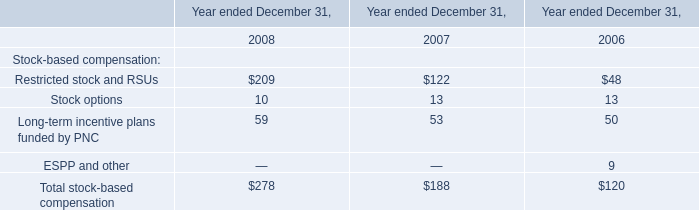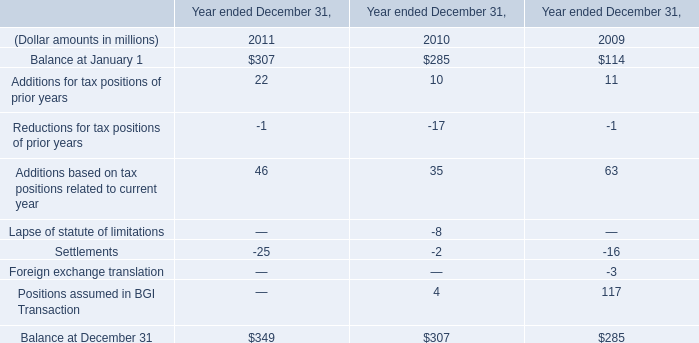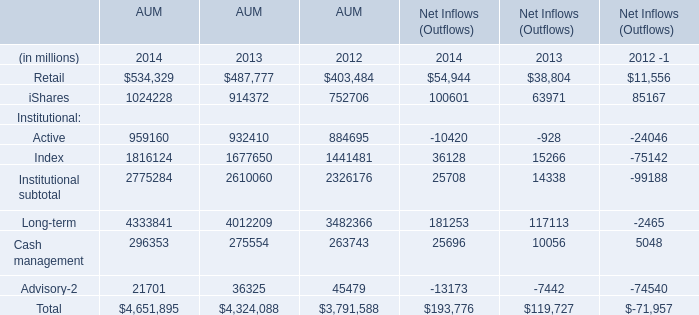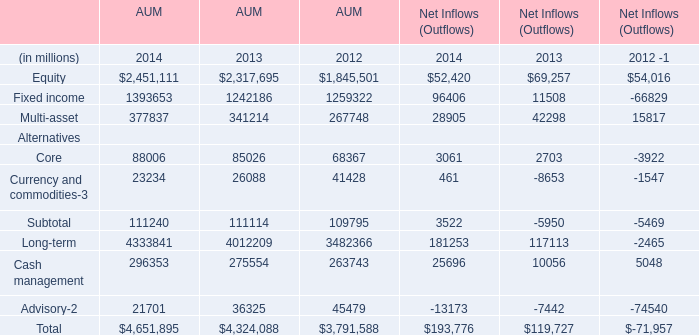What is the average amount of Retail of AUM 2013, and Fixed income of AUM 2013 ? 
Computations: ((487777.0 + 1242186.0) / 2)
Answer: 864981.5. 